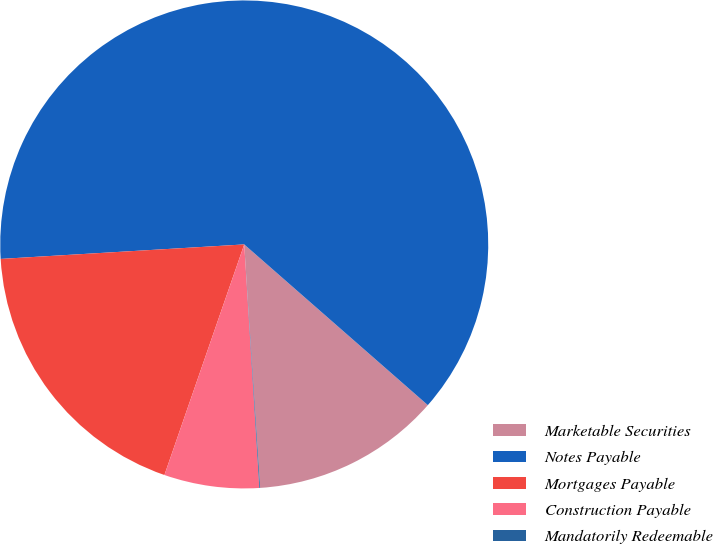Convert chart. <chart><loc_0><loc_0><loc_500><loc_500><pie_chart><fcel>Marketable Securities<fcel>Notes Payable<fcel>Mortgages Payable<fcel>Construction Payable<fcel>Mandatorily Redeemable<nl><fcel>12.52%<fcel>62.39%<fcel>18.75%<fcel>6.29%<fcel>0.05%<nl></chart> 